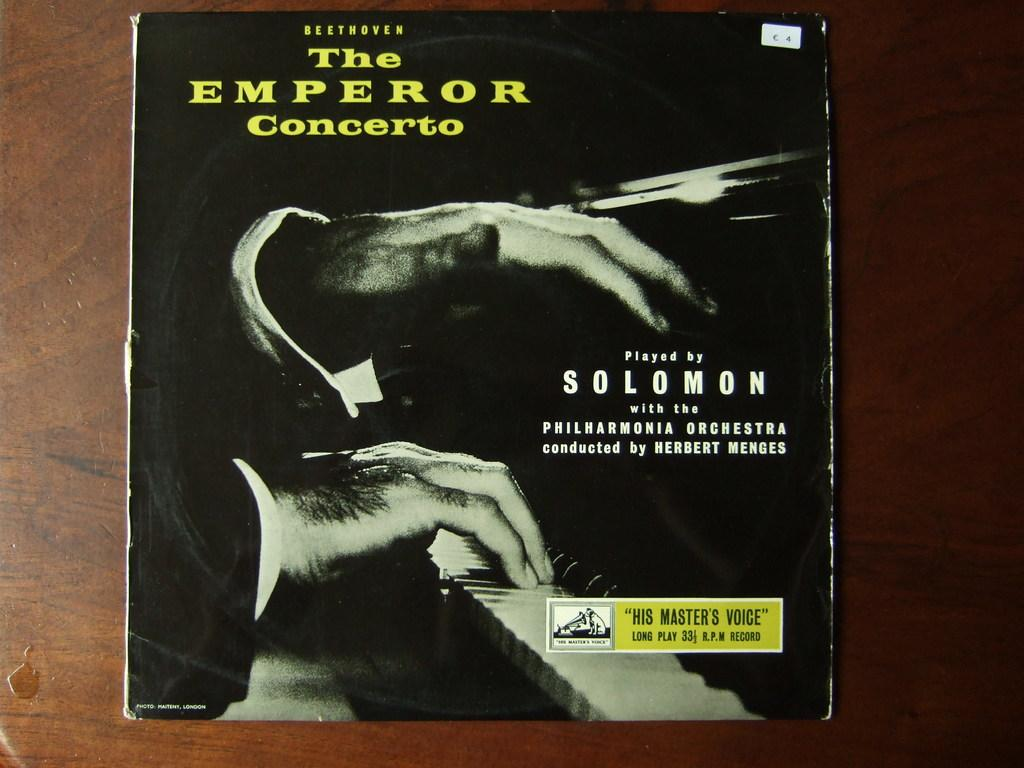<image>
Summarize the visual content of the image. An album titled the emperor concerto presented by solomon 